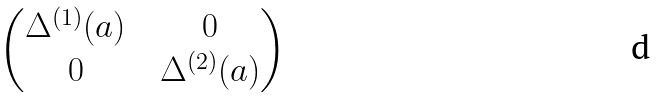Convert formula to latex. <formula><loc_0><loc_0><loc_500><loc_500>\begin{pmatrix} \Delta ^ { ( 1 ) } ( a ) \ & \ 0 \\ 0 \ & \ \Delta ^ { ( 2 ) } ( a ) \end{pmatrix}</formula> 